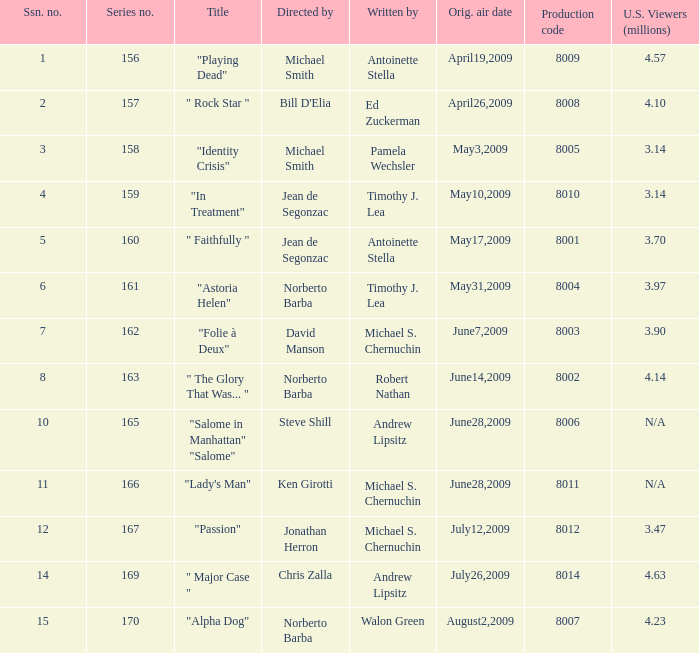How many writers write the episode whose director is Jonathan Herron? 1.0. 